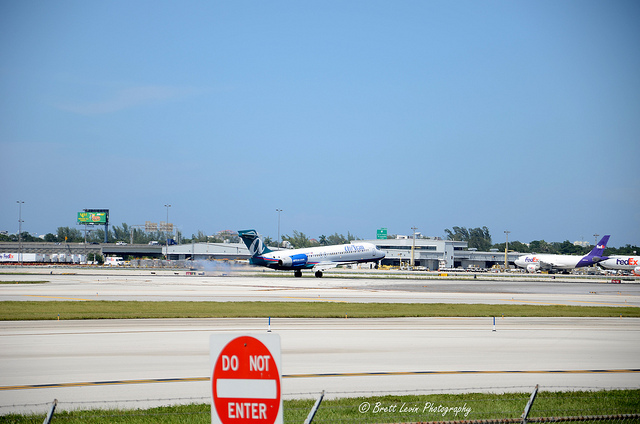Can you describe the weather conditions at the airport in this image? The weather at the airport appears to be clear and mostly sunny. There are a few faint clouds in the bright blue sky, suggesting a fair weather condition with excellent visibility for the pilots and air traffic control. 